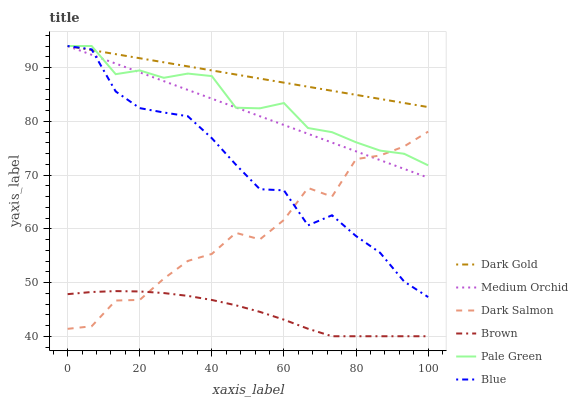Does Brown have the minimum area under the curve?
Answer yes or no. Yes. Does Dark Gold have the maximum area under the curve?
Answer yes or no. Yes. Does Dark Gold have the minimum area under the curve?
Answer yes or no. No. Does Brown have the maximum area under the curve?
Answer yes or no. No. Is Dark Gold the smoothest?
Answer yes or no. Yes. Is Dark Salmon the roughest?
Answer yes or no. Yes. Is Brown the smoothest?
Answer yes or no. No. Is Brown the roughest?
Answer yes or no. No. Does Dark Gold have the lowest value?
Answer yes or no. No. Does Pale Green have the highest value?
Answer yes or no. Yes. Does Brown have the highest value?
Answer yes or no. No. Is Brown less than Dark Gold?
Answer yes or no. Yes. Is Blue greater than Brown?
Answer yes or no. Yes. Does Brown intersect Dark Gold?
Answer yes or no. No. 